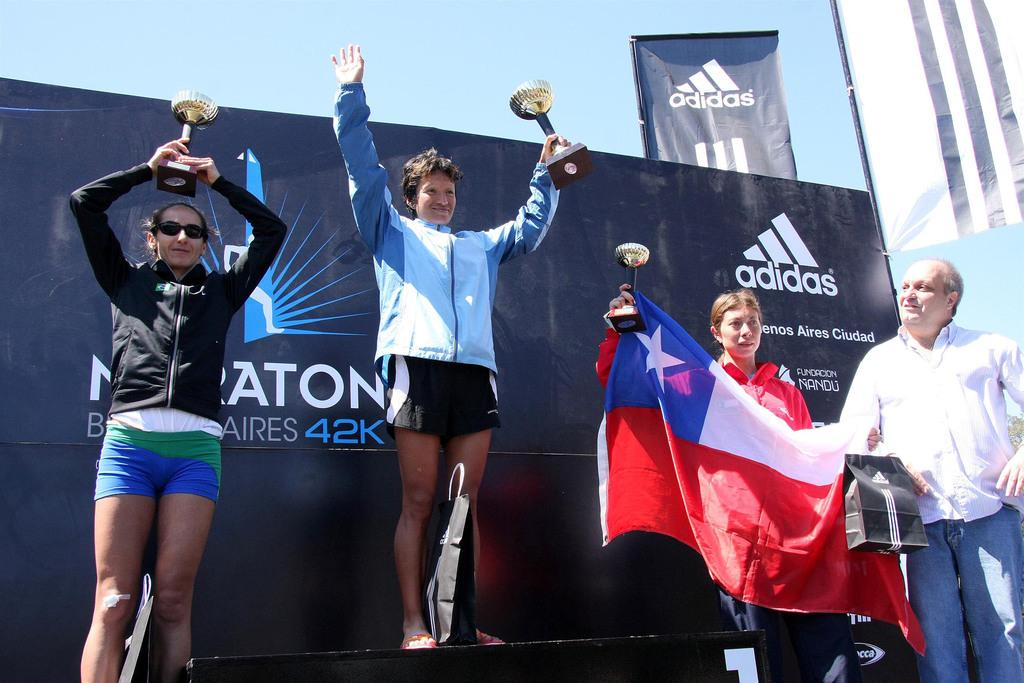<image>
Provide a brief description of the given image. The winner of the Buenos Aires marathon celebrates her victory on a podium. 